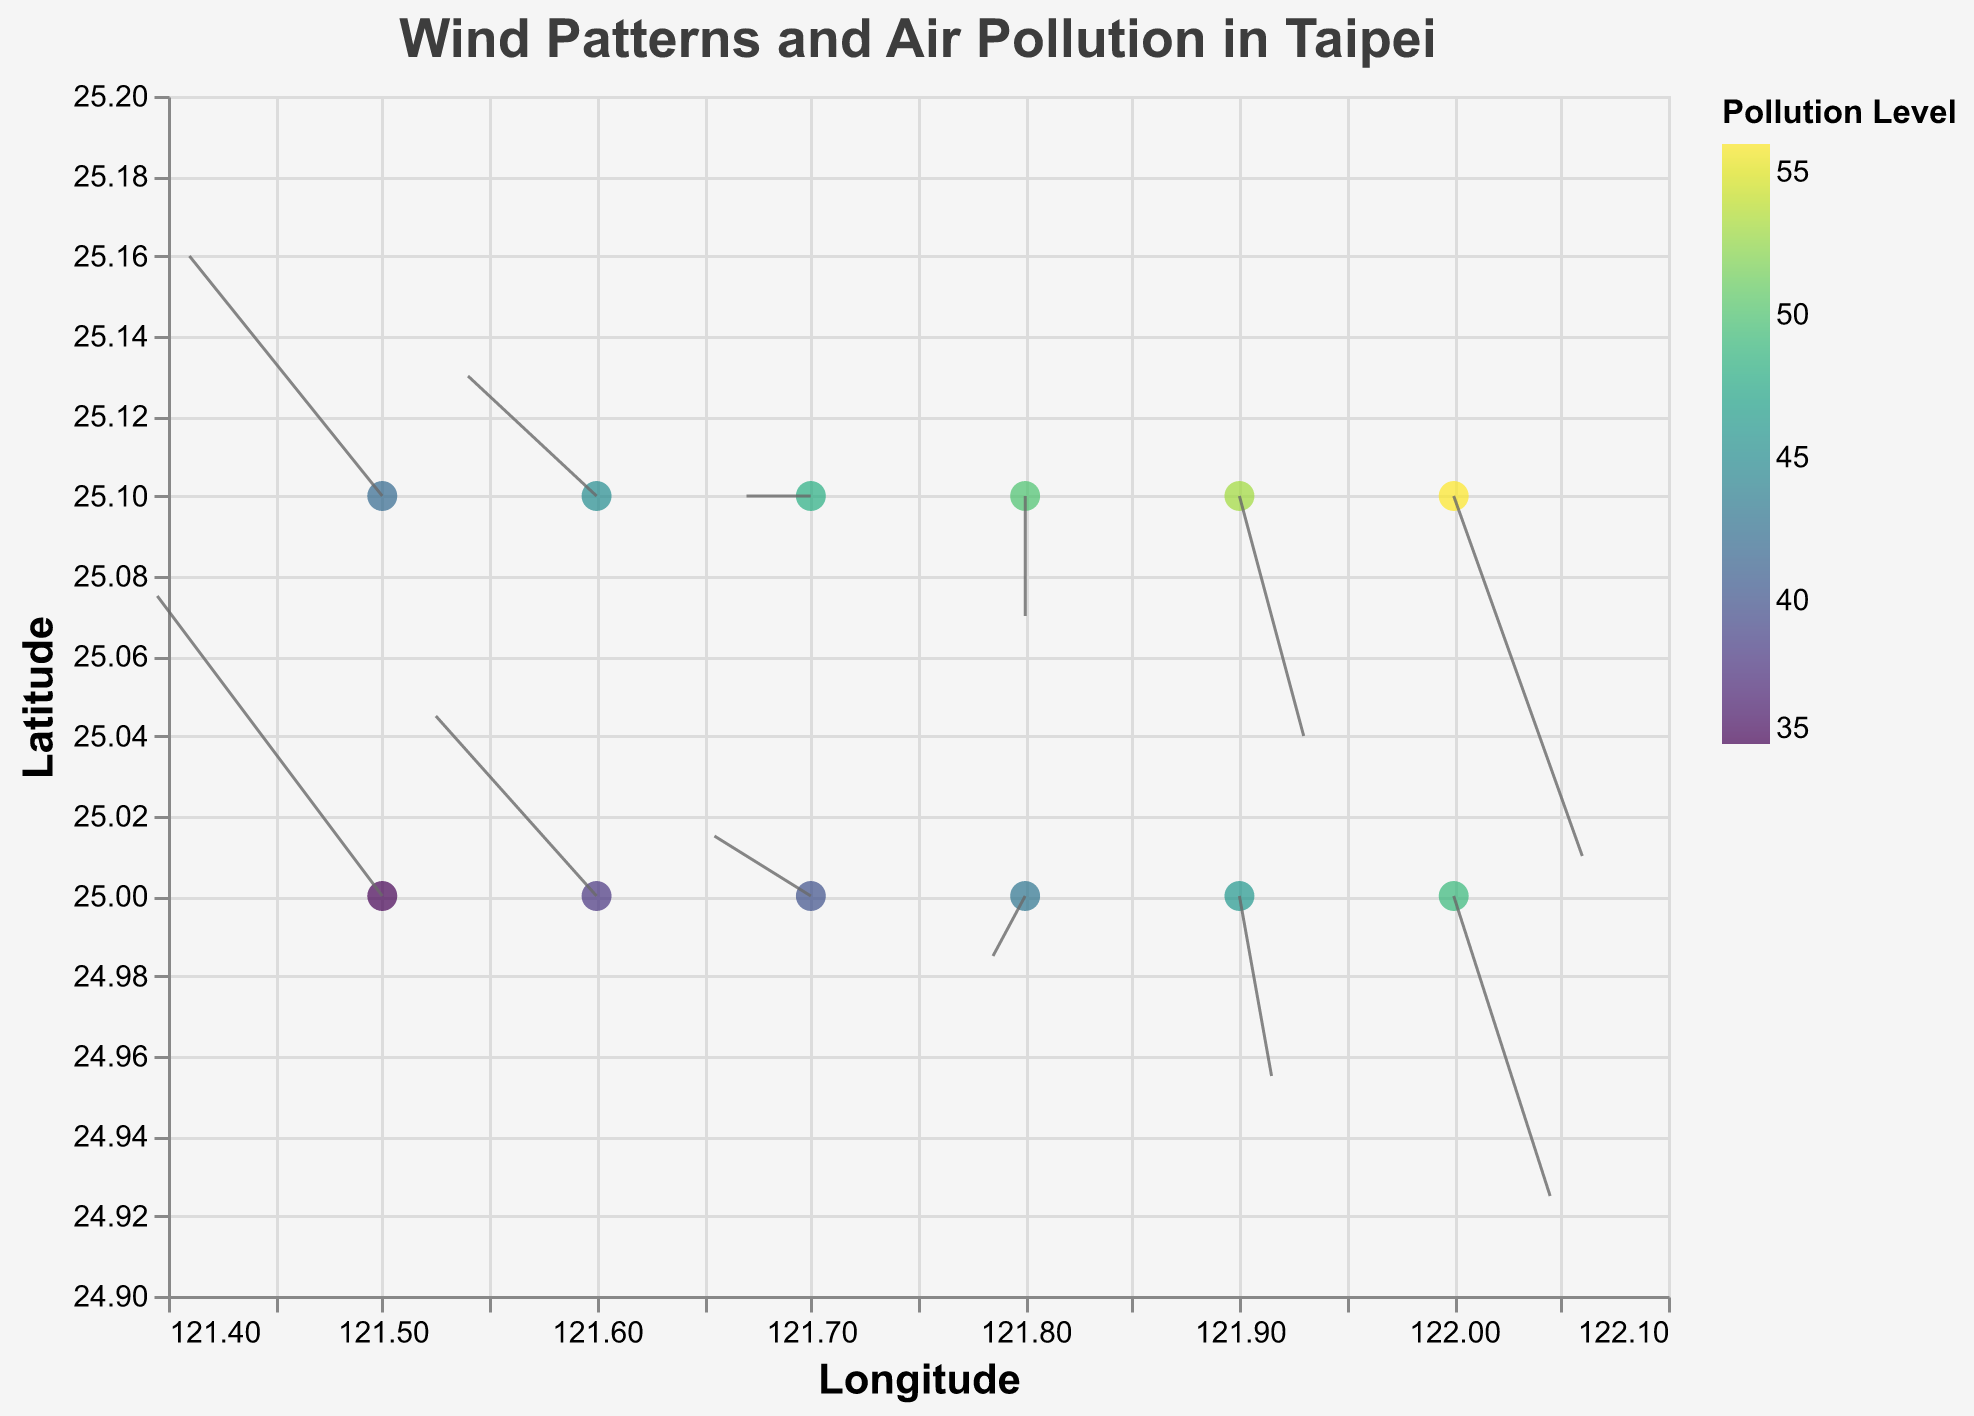How many data points are shown in the figure? There are 12 pairs of (x, y) coordinates, which represent the number of data points.
Answer: 12 What is the highest pollution level shown on the figure? The highest pollution level in the data is 56, which is identified by looking at the "pollution_level" attribute.
Answer: 56 In which direction does the wind generally blow, and how might it affect pollution levels in Taipei? By observing the vectors (u, v), it is clear that the wind generally blows from west to east. This west-to-east movement could carry air pollutants from the western regions to the eastern regions, potentially increasing pollution levels in the east.
Answer: West to East Which location has a pollution level of 45, and what are the wind components (u, v) at that location? The location (121.6, 25.1) has a pollution level of 45, and at this location, the wind components are u = -1.2 and v = 0.6. This means the wind is blowing slightly south-eastward.
Answer: (121.6, 25.1), u = -1.2, v = 0.6 What is the average pollution level across all data points? Summing up all the pollution levels (35 + 42 + 38 + 45 + 40 + 48 + 43 + 50 + 46 + 53 + 49 + 56) gives 545. Dividing the total (545) by the number of data points (12) gives the average pollution level. 545 / 12 = 45.42.
Answer: 45.42 At location (121.9, 25.0), what are the wind vector components, and what is the pollution level? At location (121.9, 25.0), the wind vector components are u = 0.3 and v = -0.9. The pollution level at this location is 46, indicating the wind is blowing south-eastward.
Answer: u = 0.3, v = -0.9, pollution level = 46 Compare the pollution levels between locations (121.5, 25.0) and (122.0, 25.1). Which location has higher pollution? The pollution level at (121.5, 25.0) is 35, and at (122.0, 25.1), it is 56. Therefore, (122.0, 25.1) has a higher pollution level.
Answer: (122.0, 25.1) What is the range of pollution levels shown in the figure? The minimum pollution level is 35 and the maximum is 56, so the range is 56 - 35.
Answer: 21 Do the wind vectors show any significant changes near the eastern edge of the plot? If so, describe them. Near the eastern edge (around 122.0, 25.0), the wind vectors shift direction from mostly neutral or westerly to more pronounced easterly. This may indicate a significant change in wind patterns near the eastern edge.
Answer: Yes, shift to more pronounced easterly Is there a correlation between wind direction and pollution levels? For example, do pollution levels increase with certain wind directions? Observing the data, pollution levels tend to increase as the wind vectors shift from negative to positive u components, indicating that eastward winds might carry pollutants to areas with initially lower pollution levels.
Answer: Yes, eastward winds seem to carry pollutants 